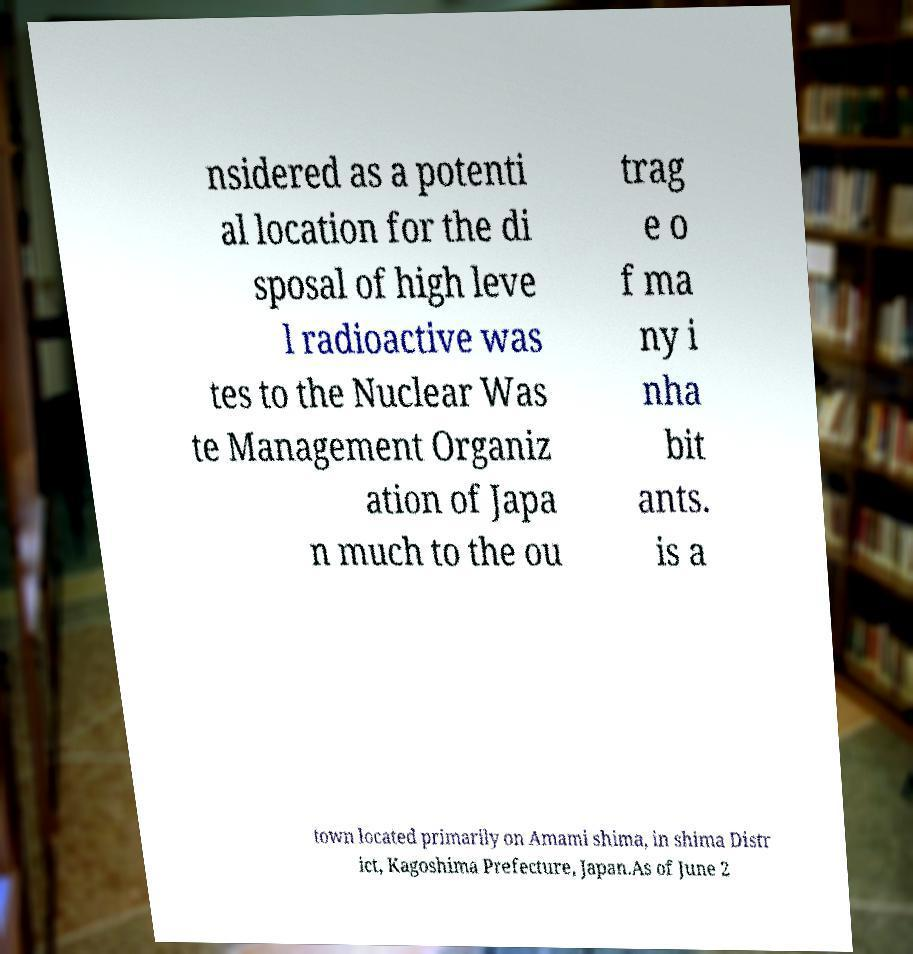Please identify and transcribe the text found in this image. nsidered as a potenti al location for the di sposal of high leve l radioactive was tes to the Nuclear Was te Management Organiz ation of Japa n much to the ou trag e o f ma ny i nha bit ants. is a town located primarily on Amami shima, in shima Distr ict, Kagoshima Prefecture, Japan.As of June 2 